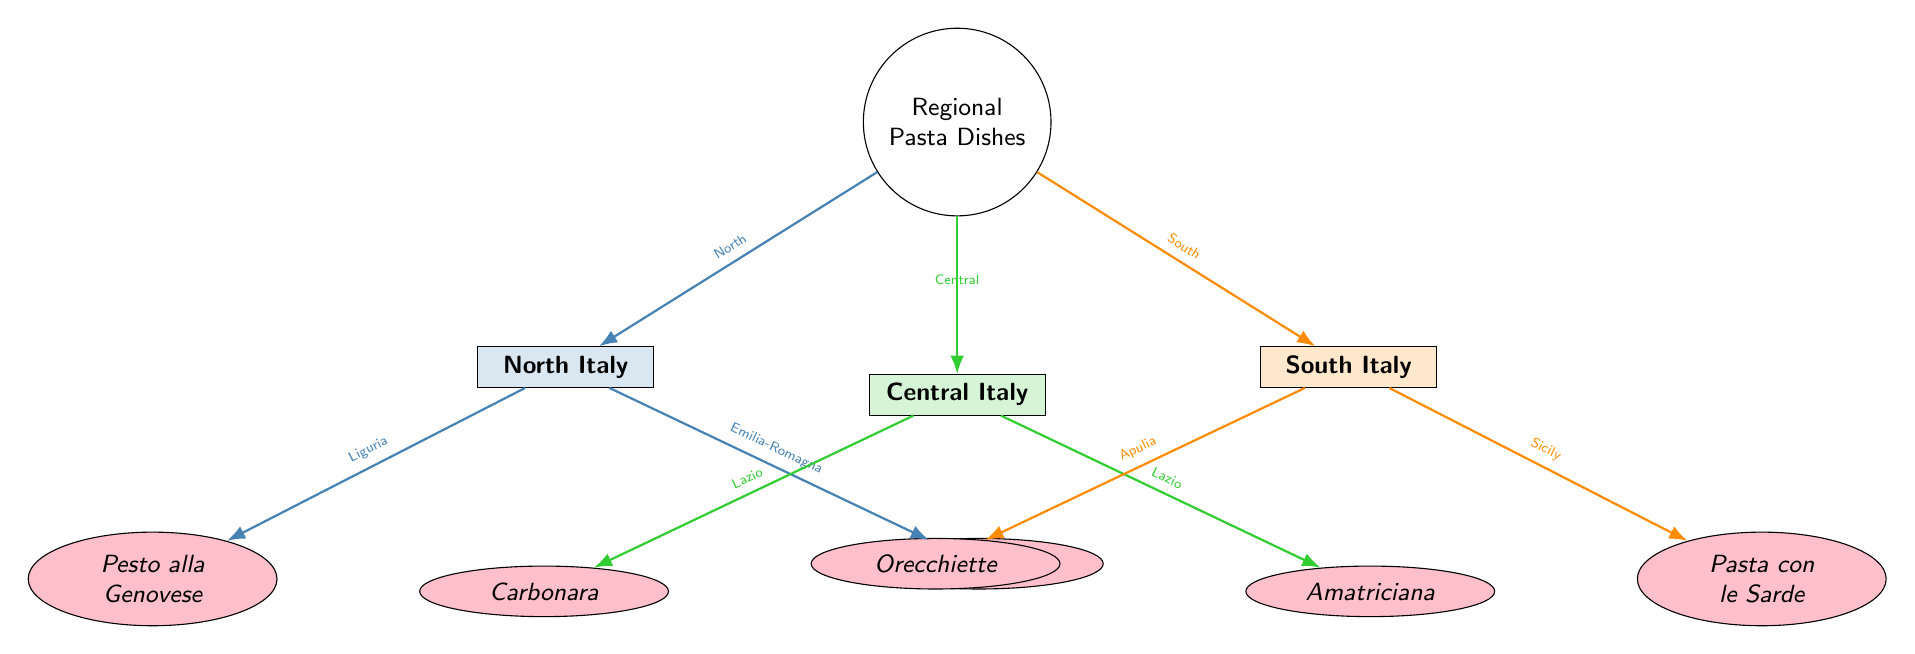What are the two regional pasta dishes from North Italy? The diagram shows two arrows leading from the "North Italy" region to the dishes. These dishes are labeled as "Pesto alla Genovese" and "Tortellini."
Answer: Pesto alla Genovese, Tortellini How many regions are represented in the diagram? The diagram features three regions: North Italy, Central Italy, and South Italy, which can be counted as three distinct nodes connected to the main node.
Answer: 3 In which region is Carbonara traditionally found? The diagram indicates that Carbonara is connected to the "Central Italy" region. The arrow leads specifically from Central Italy to the dish Carbonara, revealing its association.
Answer: Central Italy Which dish is associated with Sicily? The diagram shows that "Pasta con le Sarde" is connected to the "South Italy" region, with an arrow indicating the dish’s provenance. Upon examining the regional arrows and the associated dishes, this is identified as the dish linked to Sicily.
Answer: Pasta con le Sarde What color represents pasta dishes from South Italy? The diagram uses different colors for the regions, with South Italy being represented in an orange hue (RGB 255, 140, 0). By looking at the node filled with this color, we can confirm this representation.
Answer: Orange Which two dishes are listed under Central Italy in the diagram? By reviewing the arrows that go from Central Italy, there are connections leading to "Carbonara" and "Amatriciana." Thus, these two dishes can be derived from examining their respective arrows from the regional node.
Answer: Carbonara, Amatriciana How many pasta dishes are represented in the diagram? There are six dishes total: Pesto alla Genovese, Tortellini, Carbonara, Amatriciana, Orecchiette, and Pasta con le Sarde. Counting each of the connected dish nodes shows that there are exactly six pasta dishes illustrated in this diagram.
Answer: 6 Which dish is associated with Emilia-Romagna? The diagram indicates that "Tortellini" is connected with the area of Emilia-Romagna through an arrow pointing from the North Italy region to the dish. This connection identifies Tortellini as associated with Emilia-Romagna.
Answer: Tortellini What is the relationship between the main node and the regions in the diagram? The main node, "Regional Pasta Dishes," connects to the three regional nodes (North Italy, Central Italy, South Italy) with arrows, establishing that the regions are classifications of pasta dishes. This indicates a hierarchical relationship with the main node encompassing the regional categories.
Answer: Hierarchical relationship 